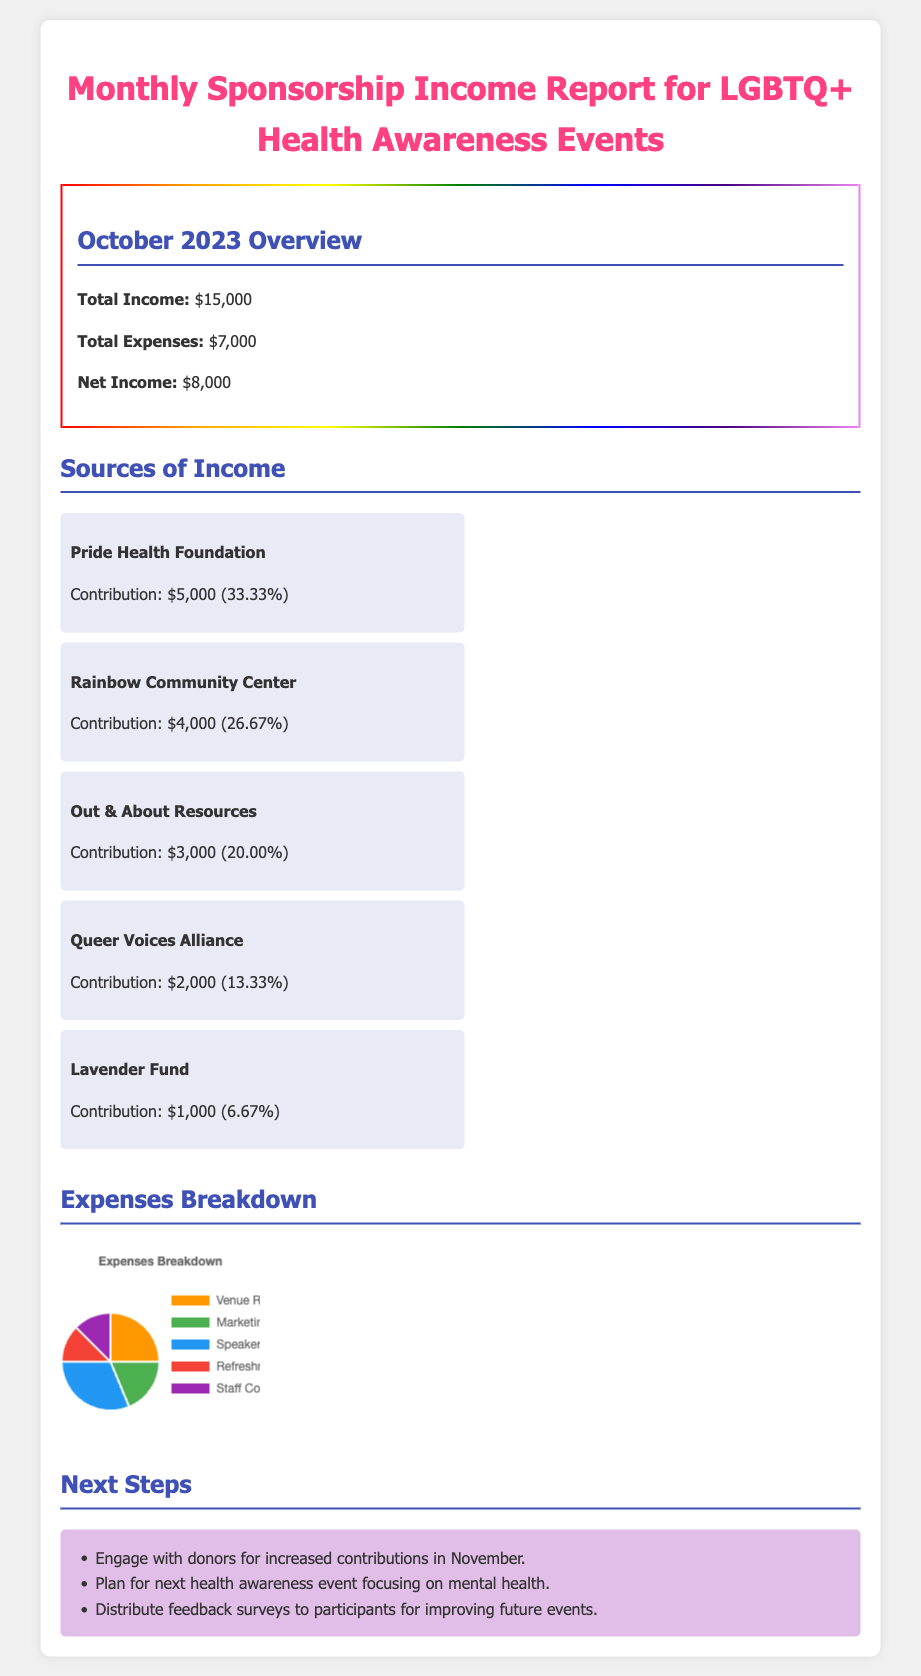What is the total income for October 2023? The total income for October 2023 is clearly stated in the document.
Answer: $15,000 What percentage did Pride Health Foundation contribute? The contribution percentage for each donor is provided, and specifically for Pride Health Foundation.
Answer: 33.33% What is the net income reported? The net income is calculated as total income minus total expenses, and this amount is listed.
Answer: $8,000 How much did Rainbow Community Center contribute? The specific contribution amount for Rainbow Community Center is detailed in the document.
Answer: $4,000 What are the expenses related to Speaker Fees? The breakdown of expenses lists specific amounts allocated for various categories, including Speaker Fees.
Answer: $2,500 Which organization had the least contribution? The document lists all donors and their contributions, making it possible to determine which one is the smallest.
Answer: Lavender Fund What is one of the next steps mentioned in the report? The report outlines several next steps, each aimed at improving future events.
Answer: Engage with donors for increased contributions in November What is the total amount spent on Refreshments? The expenses breakdown specifies the amount allocated for Refreshments in the financial report.
Answer: $1,000 What is the color associated with Marketing Materials in the chart? The chart uses specific colors to represent different expenses, including Marketing Materials.
Answer: Green 